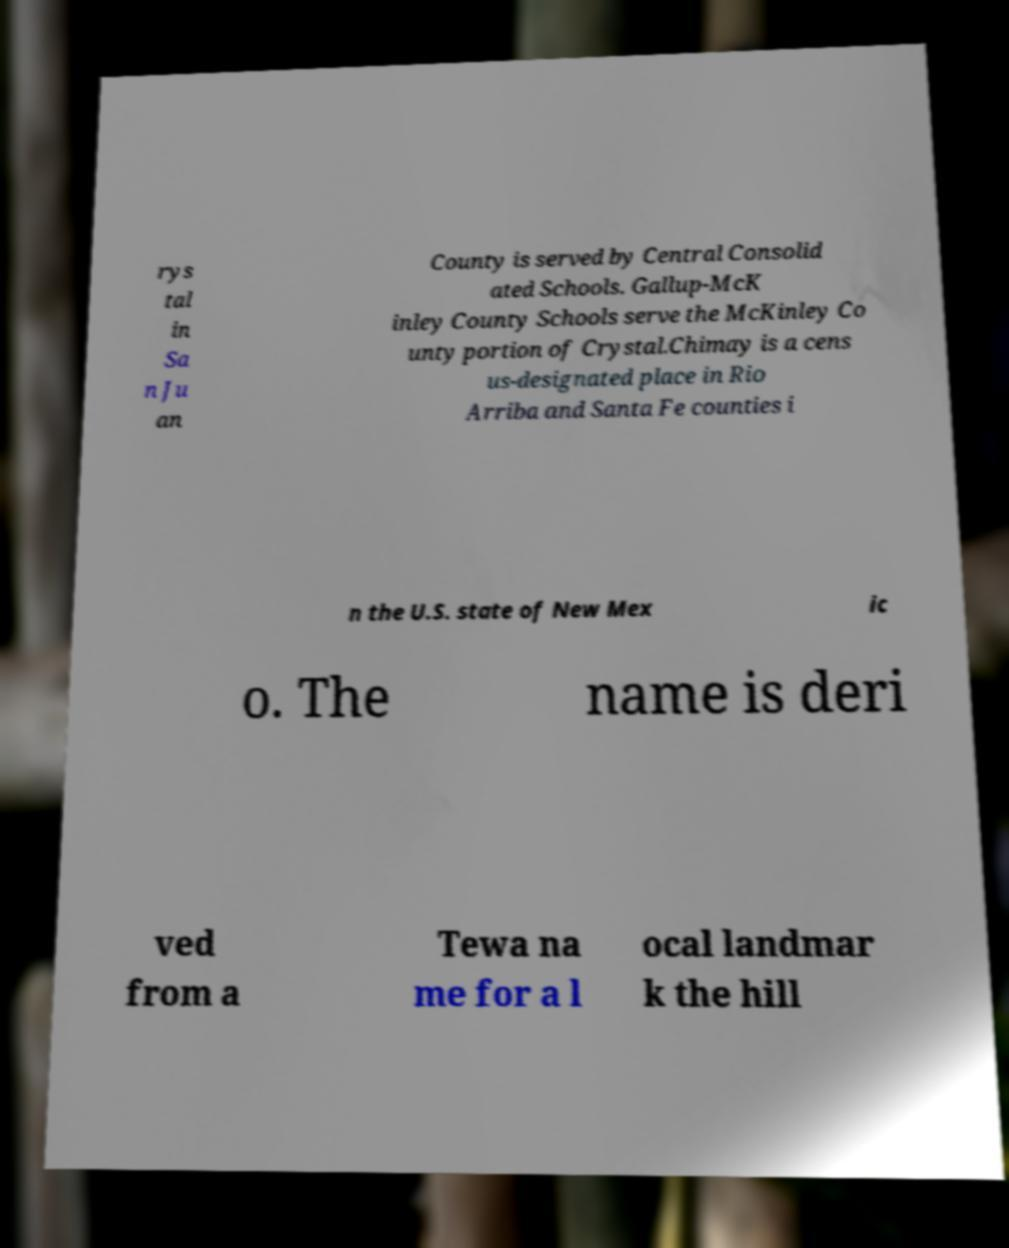Can you read and provide the text displayed in the image?This photo seems to have some interesting text. Can you extract and type it out for me? rys tal in Sa n Ju an County is served by Central Consolid ated Schools. Gallup-McK inley County Schools serve the McKinley Co unty portion of Crystal.Chimay is a cens us-designated place in Rio Arriba and Santa Fe counties i n the U.S. state of New Mex ic o. The name is deri ved from a Tewa na me for a l ocal landmar k the hill 